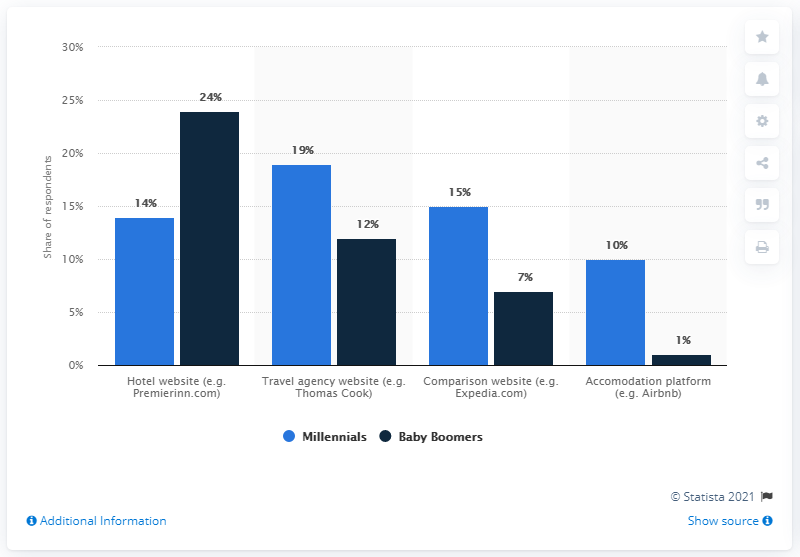Give some essential details in this illustration. The average of the blue bars is 14.5. The highest dark blue bar has a value of 24. 